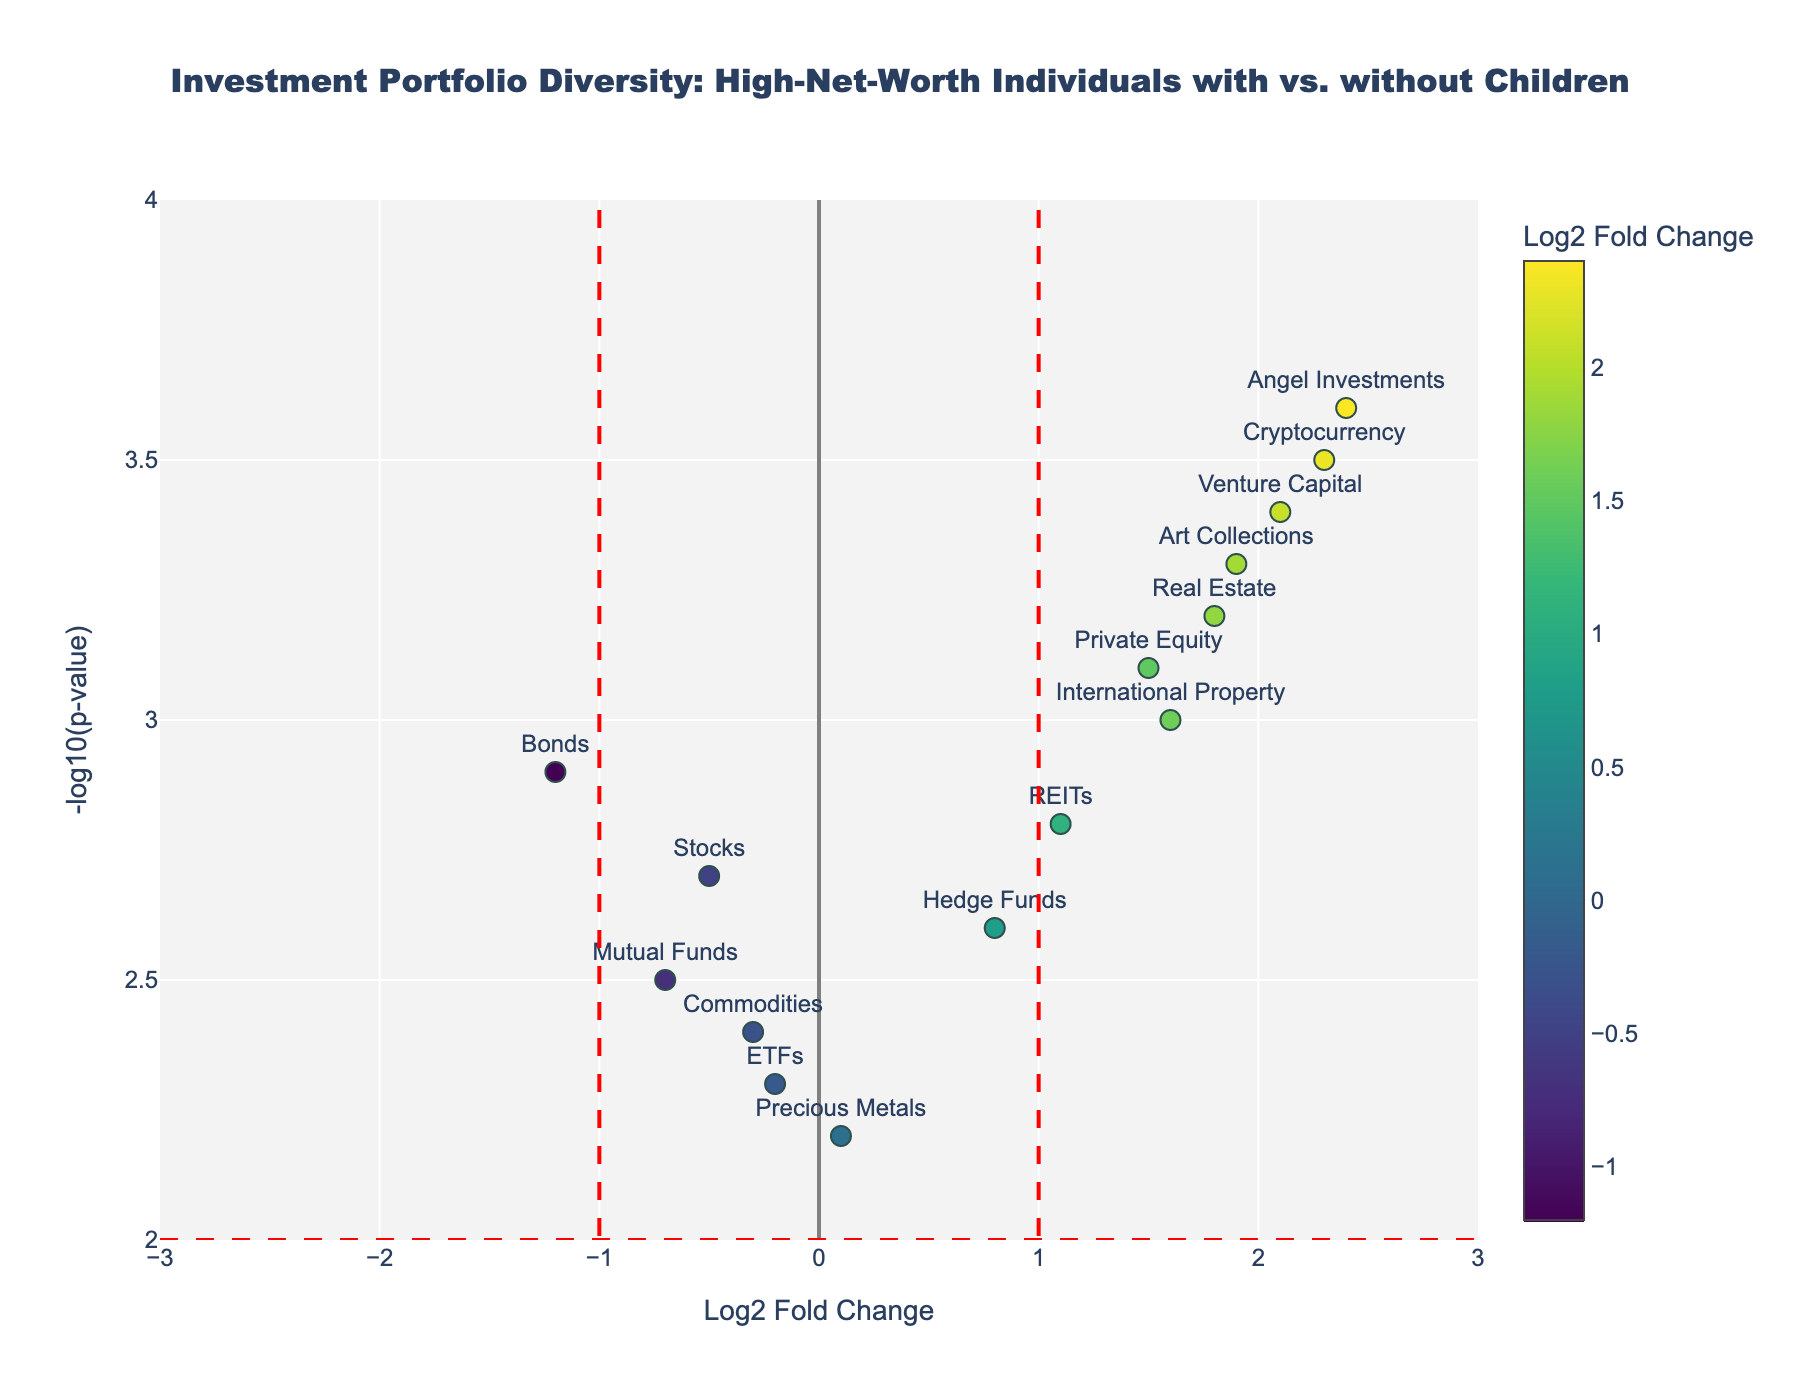How many investment types have a positive Log2 Fold Change? Count the number of points on the right side of the vertical line at Log2 Fold Change = 0. There are 9 points (Real Estate, Cryptocurrency, Private Equity, Hedge Funds, Art Collections, Venture Capital, International Property, Angel Investments, REITs).
Answer: 9 Which investment type has the highest -log10(p-value)? Identify the highest point on the vertical axis. The highest value is 3.6 for Angel Investments.
Answer: Angel Investments What is the Log2 Fold Change value of the 'Bonds' investment type? Locate the position of 'Bonds' on the horizontal axis. Bonds has a Log2 Fold Change value of -1.2.
Answer: -1.2 Compare Angel Investments and Bonds in terms of -log10(p-value). Which one is higher? Angel Investments has a -log10(p-value) of 3.6 and Bonds has 2.9. 3.6 is higher than 2.9.
Answer: Angel Investments What is the range of -log10(p-value) values in the plot? Identify the minimum and maximum values on the vertical axis. The range goes from 2.2 (Precious Metals) to 3.6 (Angel Investments).
Answer: 2.2 to 3.6 Which investments show both statistical significance (>-log10(p-value) of 2) and positive portfolio change (Log2 Fold Change > 1)? Look for points above the horizontal line at y=2 and right of the vertical line at x=1. These are Real Estate, Cryptocurrency, Private Equity, Art Collections, Venture Capital, Angel Investments, and International Property.
Answer: 7 How many investments have a Log2 Fold Change between -1 and 1? Count the number of points between the vertical lines at x=-1 and x=1. These are Stocks, Hedge Funds, Commodities, Mutual Funds, ETFs, and Precious Metals.
Answer: 6 What is the average -log10(p-value) of the investments with negative Log2 Fold Change? Sum the -log10(p-values) of Stocks (2.7), Bonds (2.9), Commodities (2.4), Mutual Funds (2.5), and ETFs (2.3) and divide by 5. (2.7 + 2.9 + 2.4 + 2.5 + 2.3) / 5 = 2.56
Answer: 2.56 